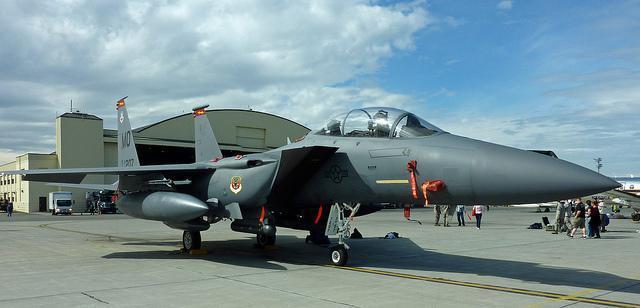How many orange papers are on the toilet?
Give a very brief answer. 0. 